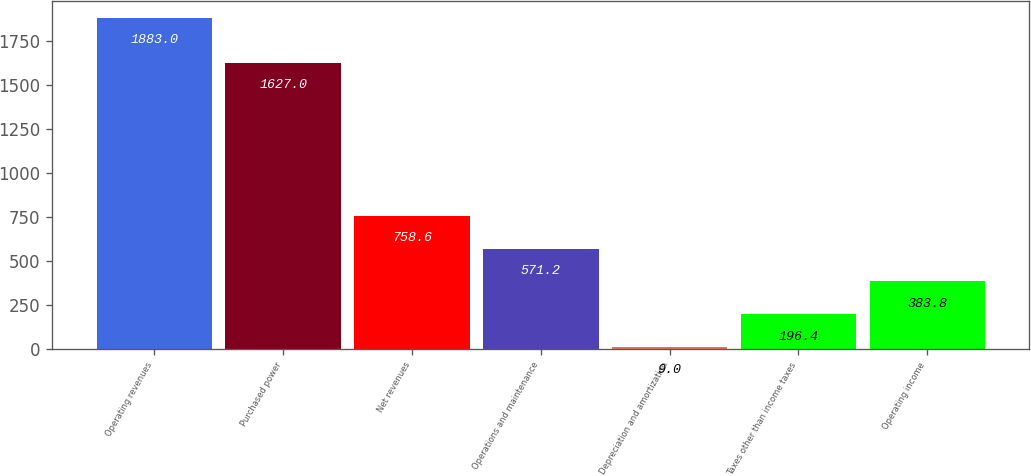Convert chart. <chart><loc_0><loc_0><loc_500><loc_500><bar_chart><fcel>Operating revenues<fcel>Purchased power<fcel>Net revenues<fcel>Operations and maintenance<fcel>Depreciation and amortization<fcel>Taxes other than income taxes<fcel>Operating income<nl><fcel>1883<fcel>1627<fcel>758.6<fcel>571.2<fcel>9<fcel>196.4<fcel>383.8<nl></chart> 